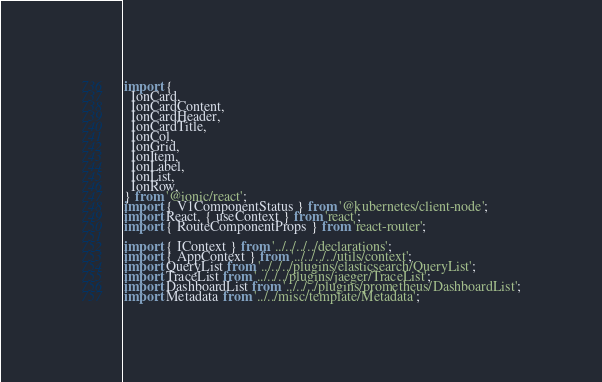Convert code to text. <code><loc_0><loc_0><loc_500><loc_500><_TypeScript_>import {
  IonCard,
  IonCardContent,
  IonCardHeader,
  IonCardTitle,
  IonCol,
  IonGrid,
  IonItem,
  IonLabel,
  IonList,
  IonRow,
} from '@ionic/react';
import { V1ComponentStatus } from '@kubernetes/client-node';
import React, { useContext } from 'react';
import { RouteComponentProps } from 'react-router';

import { IContext } from '../../../../declarations';
import { AppContext } from '../../../../utils/context';
import QueryList from '../../../plugins/elasticsearch/QueryList';
import TraceList from '../../../plugins/jaeger/TraceList';
import DashboardList from '../../../plugins/prometheus/DashboardList';
import Metadata from '../../misc/template/Metadata';
</code> 